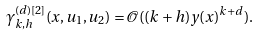Convert formula to latex. <formula><loc_0><loc_0><loc_500><loc_500>\gamma _ { k , h } ^ { ( d ) [ 2 ] } ( x , u _ { 1 } , u _ { 2 } ) = \mathcal { O } ( ( k + h ) y ( x ) ^ { k + d } ) .</formula> 